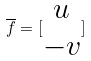Convert formula to latex. <formula><loc_0><loc_0><loc_500><loc_500>\overline { f } = [ \begin{matrix} u \\ - v \end{matrix} ]</formula> 